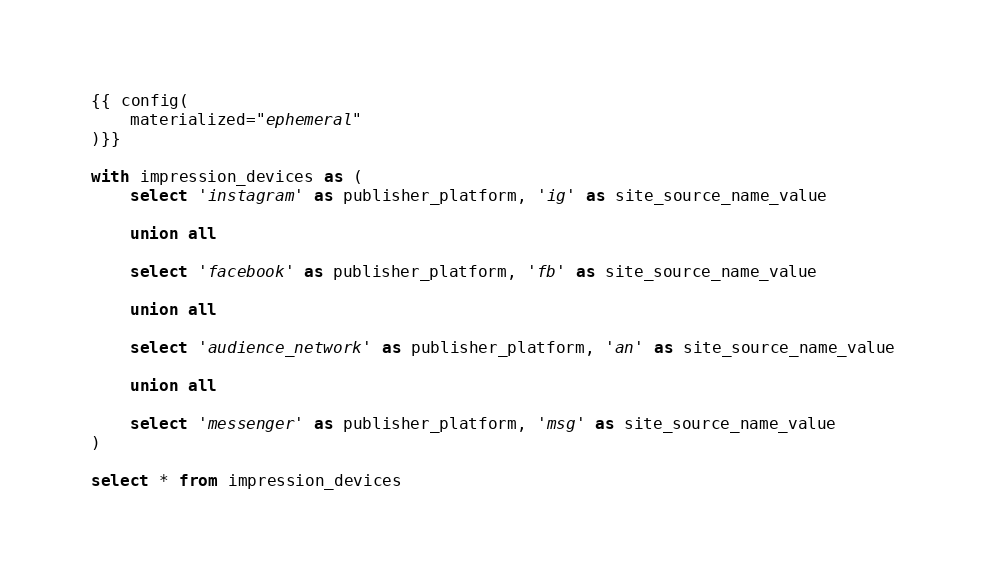<code> <loc_0><loc_0><loc_500><loc_500><_SQL_>{{ config(
    materialized="ephemeral"
)}}

with impression_devices as (
    select 'instagram' as publisher_platform, 'ig' as site_source_name_value

    union all

    select 'facebook' as publisher_platform, 'fb' as site_source_name_value

    union all

    select 'audience_network' as publisher_platform, 'an' as site_source_name_value

    union all

    select 'messenger' as publisher_platform, 'msg' as site_source_name_value
)

select * from impression_devices</code> 